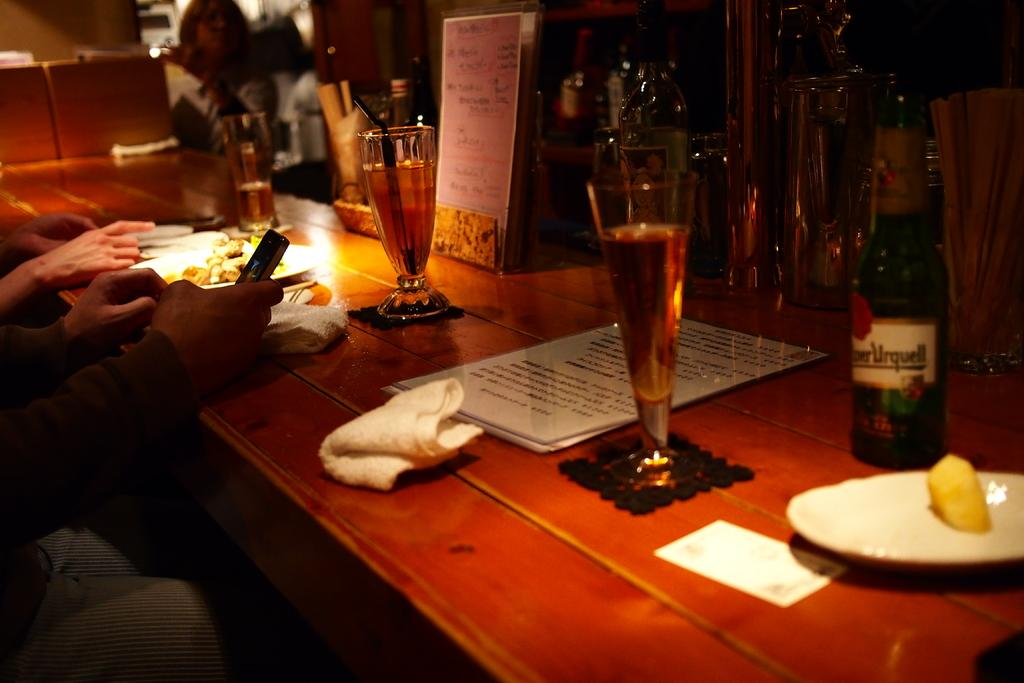How many people are in the image? There is a group of people in the image. What can be seen besides the people in the image? There is a bottle, glasses, a menu card, and plates on the table in the image. What might the people be using the glasses for? The glasses might be used for drinking, as they are typically used for holding beverages. What can be used to make a selection of food or drinks in the image? There is a menu card in the image that can be used for making a selection. What type of shop can be seen in the image? There is no shop present in the image. 